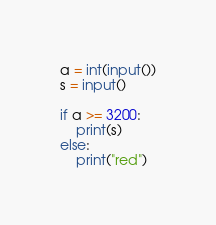Convert code to text. <code><loc_0><loc_0><loc_500><loc_500><_Python_>a = int(input())
s = input()

if a >= 3200:
    print(s)
else:
    print("red")</code> 